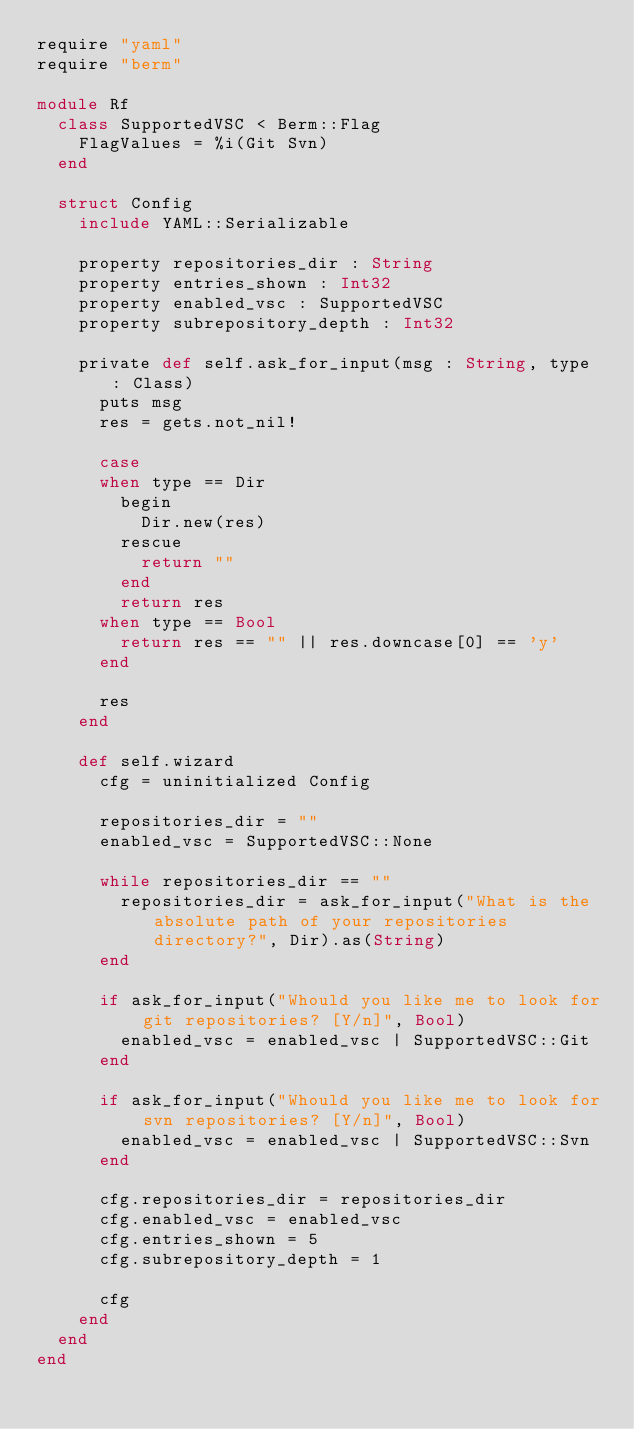<code> <loc_0><loc_0><loc_500><loc_500><_Crystal_>require "yaml"
require "berm"

module Rf
  class SupportedVSC < Berm::Flag
    FlagValues = %i(Git Svn)
  end

  struct Config
    include YAML::Serializable

    property repositories_dir : String
    property entries_shown : Int32
    property enabled_vsc : SupportedVSC
    property subrepository_depth : Int32

    private def self.ask_for_input(msg : String, type : Class)
      puts msg
      res = gets.not_nil!

      case
      when type == Dir
        begin
          Dir.new(res)
        rescue
          return ""
        end
        return res
      when type == Bool
        return res == "" || res.downcase[0] == 'y'
      end

      res
    end

    def self.wizard
      cfg = uninitialized Config

      repositories_dir = ""
      enabled_vsc = SupportedVSC::None

      while repositories_dir == ""
        repositories_dir = ask_for_input("What is the absolute path of your repositories directory?", Dir).as(String)
      end

      if ask_for_input("Whould you like me to look for git repositories? [Y/n]", Bool)
        enabled_vsc = enabled_vsc | SupportedVSC::Git
      end

      if ask_for_input("Whould you like me to look for svn repositories? [Y/n]", Bool)
        enabled_vsc = enabled_vsc | SupportedVSC::Svn
      end

      cfg.repositories_dir = repositories_dir
      cfg.enabled_vsc = enabled_vsc
      cfg.entries_shown = 5
      cfg.subrepository_depth = 1

      cfg
    end
  end
end
</code> 